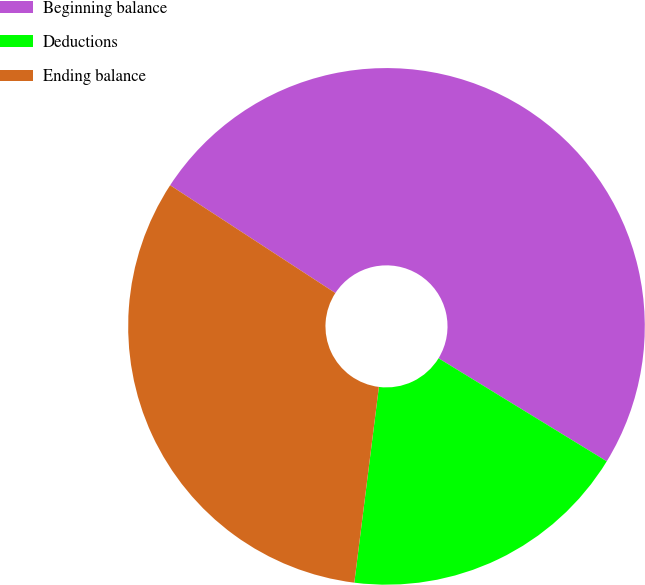<chart> <loc_0><loc_0><loc_500><loc_500><pie_chart><fcel>Beginning balance<fcel>Deductions<fcel>Ending balance<nl><fcel>49.55%<fcel>18.24%<fcel>32.21%<nl></chart> 